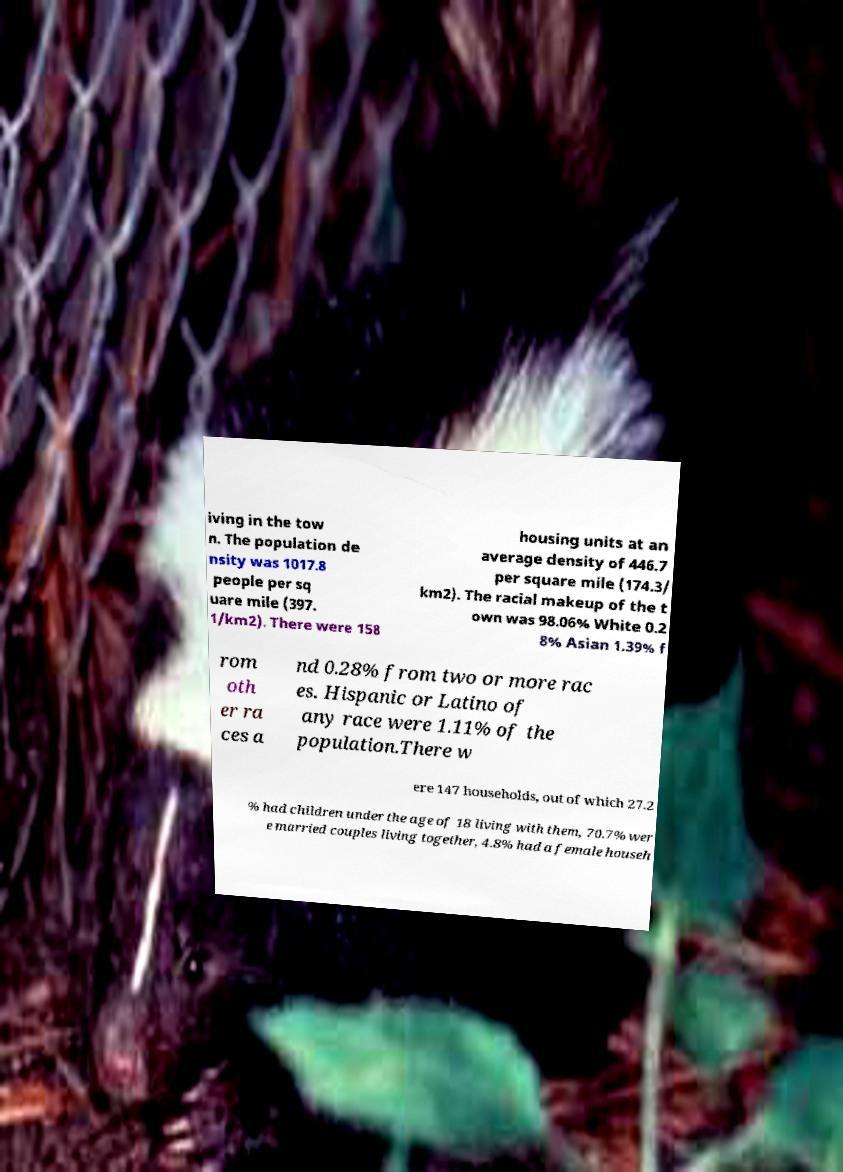Can you accurately transcribe the text from the provided image for me? iving in the tow n. The population de nsity was 1017.8 people per sq uare mile (397. 1/km2). There were 158 housing units at an average density of 446.7 per square mile (174.3/ km2). The racial makeup of the t own was 98.06% White 0.2 8% Asian 1.39% f rom oth er ra ces a nd 0.28% from two or more rac es. Hispanic or Latino of any race were 1.11% of the population.There w ere 147 households, out of which 27.2 % had children under the age of 18 living with them, 70.7% wer e married couples living together, 4.8% had a female househ 